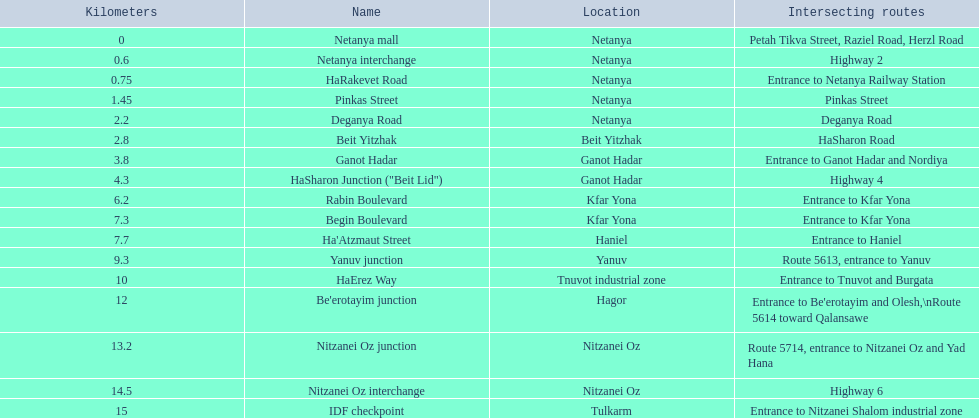What are all the diverse parts? Netanya mall, Netanya interchange, HaRakevet Road, Pinkas Street, Deganya Road, Beit Yitzhak, Ganot Hadar, HaSharon Junction ("Beit Lid"), Rabin Boulevard, Begin Boulevard, Ha'Atzmaut Street, Yanuv junction, HaErez Way, Be'erotayim junction, Nitzanei Oz junction, Nitzanei Oz interchange, IDF checkpoint. What is the overlapping route for rabin boulevard? Entrance to Kfar Yona. What part also has an overlapping route of entryway to kfar yona? Begin Boulevard. 